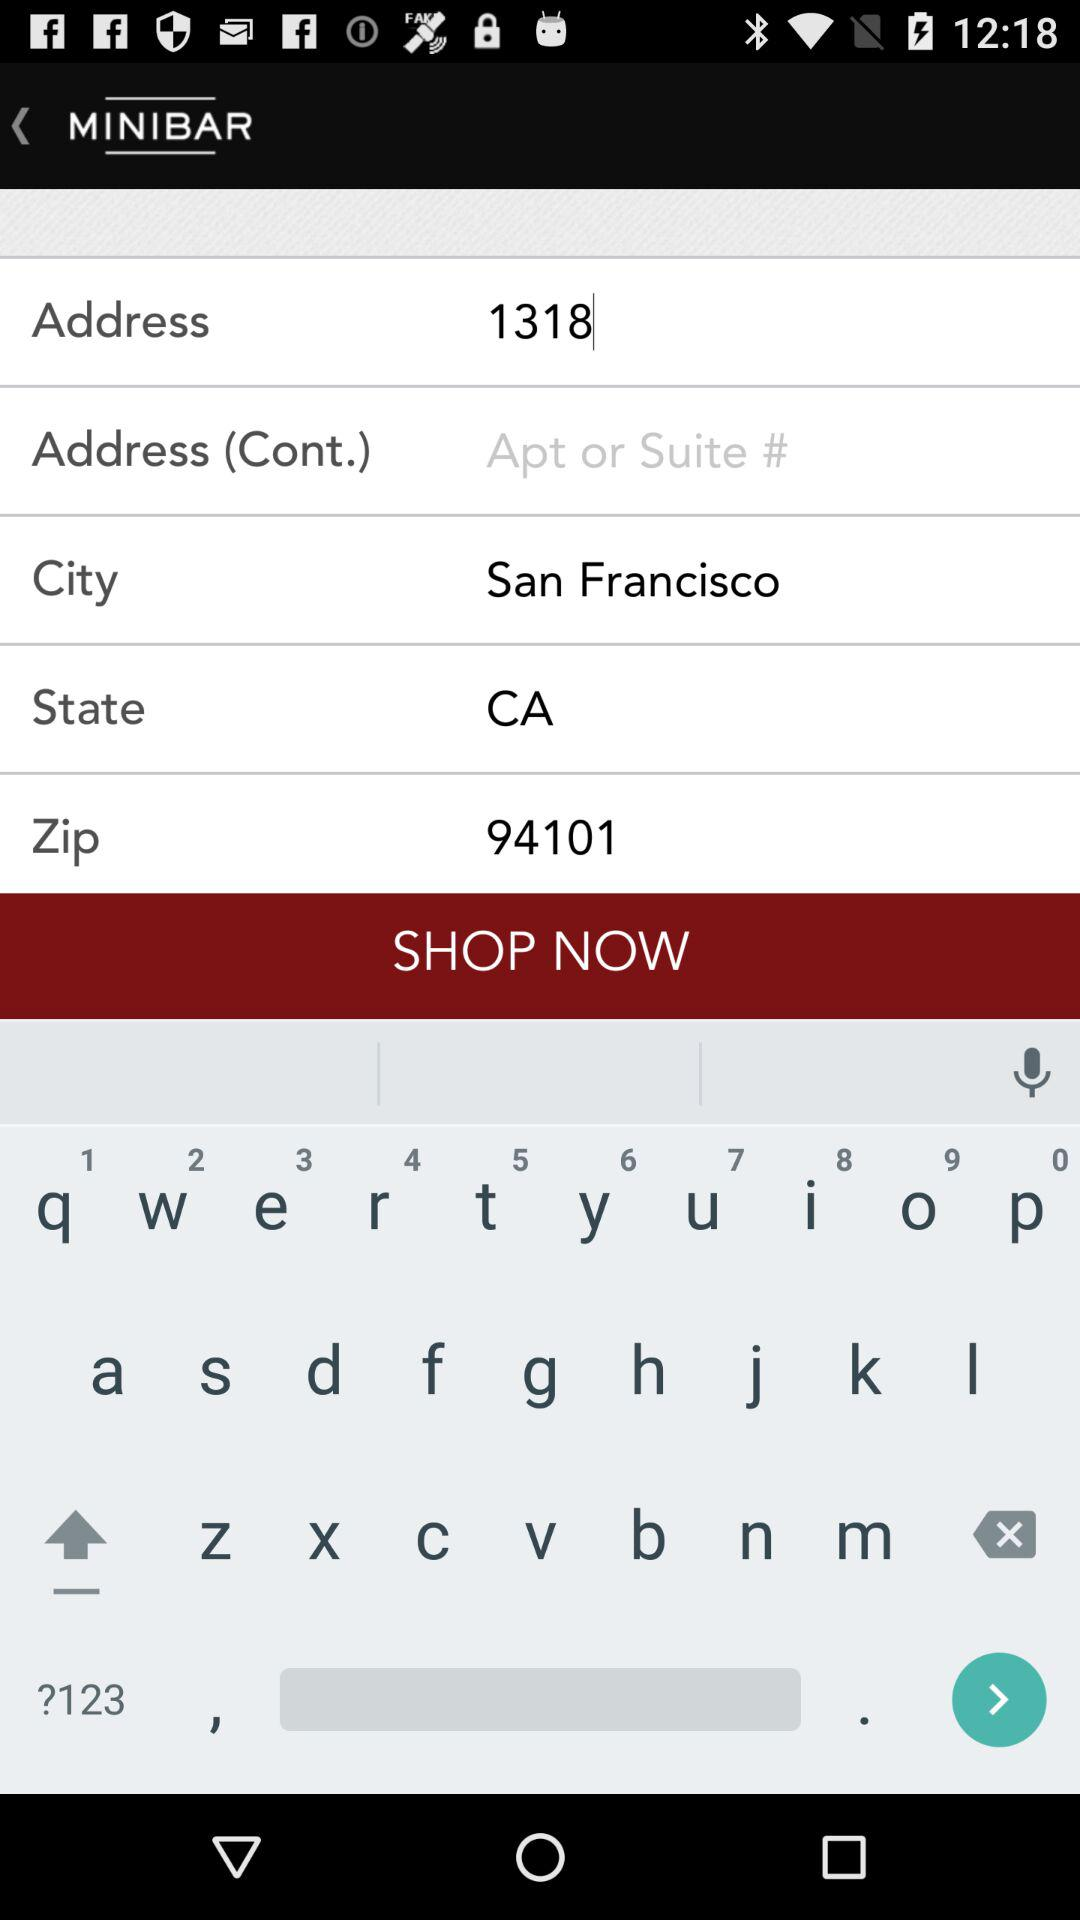What is the mentioned state? The mentioned state is California. 